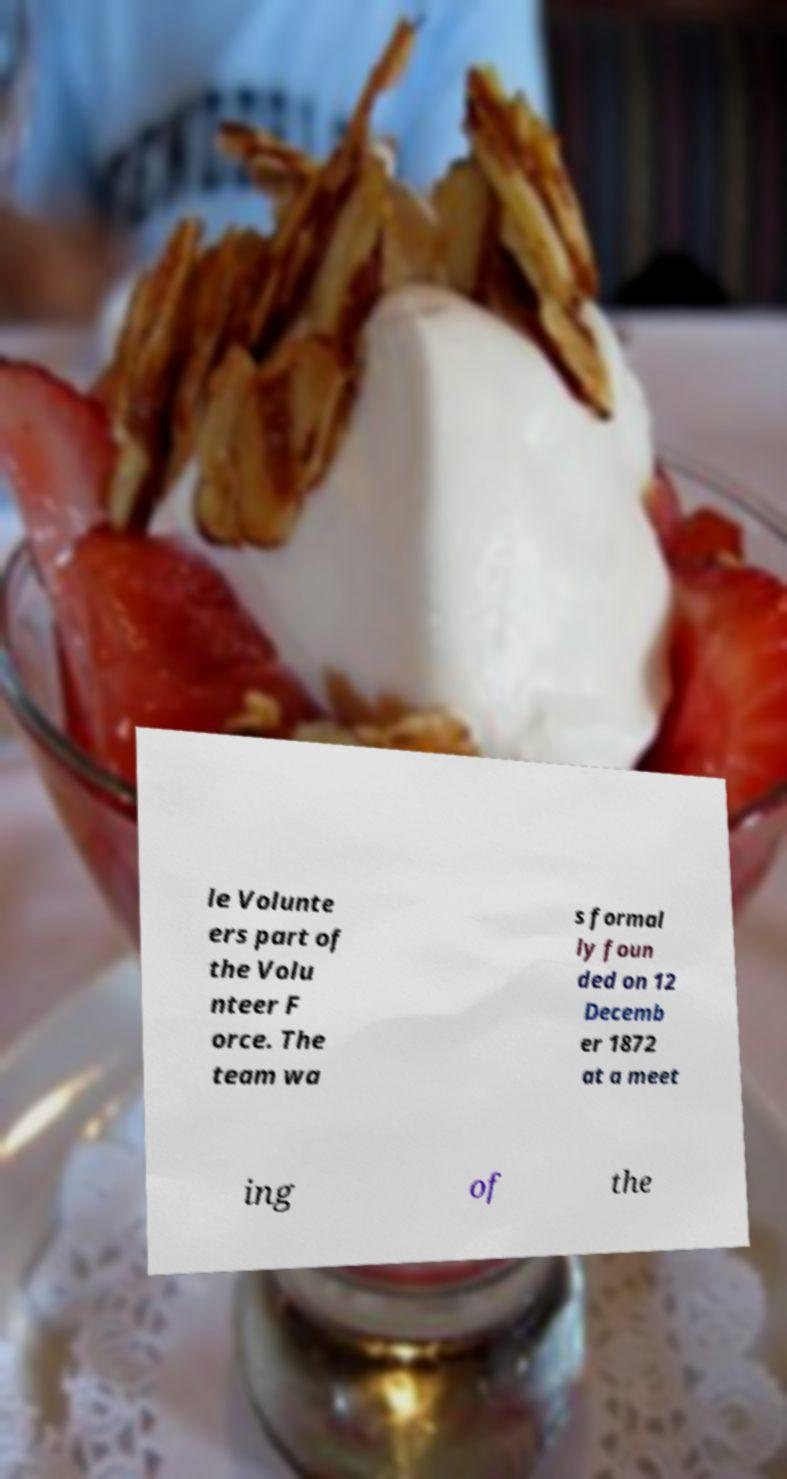I need the written content from this picture converted into text. Can you do that? le Volunte ers part of the Volu nteer F orce. The team wa s formal ly foun ded on 12 Decemb er 1872 at a meet ing of the 